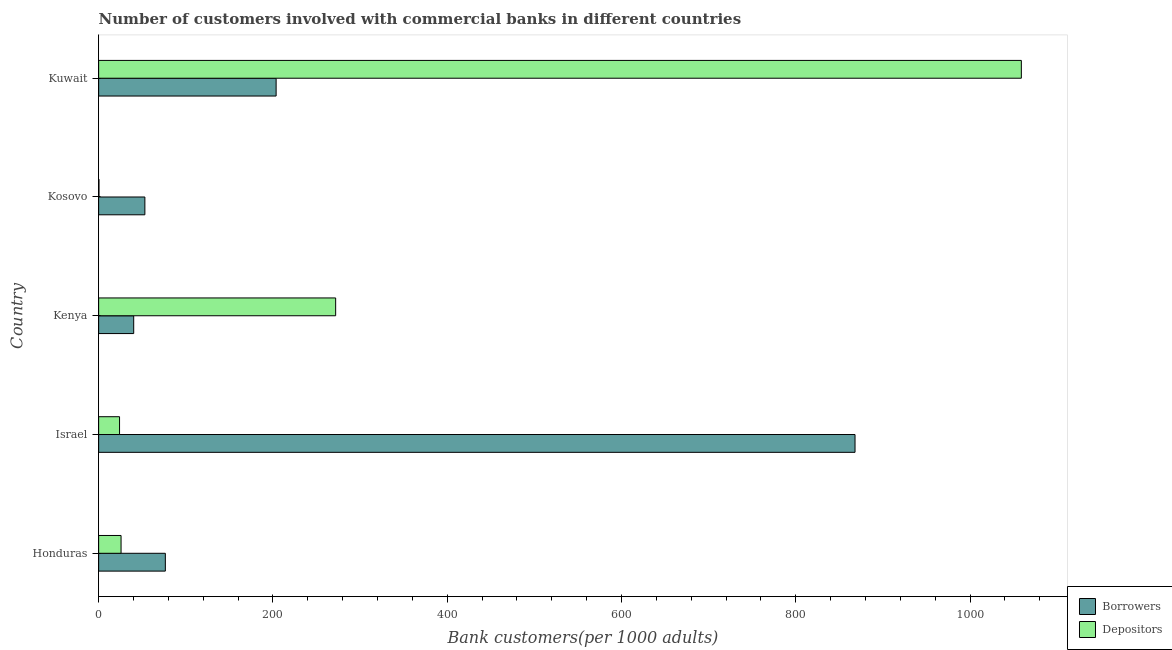How many different coloured bars are there?
Your answer should be very brief. 2. Are the number of bars per tick equal to the number of legend labels?
Ensure brevity in your answer.  Yes. How many bars are there on the 4th tick from the top?
Offer a very short reply. 2. What is the label of the 3rd group of bars from the top?
Ensure brevity in your answer.  Kenya. In how many cases, is the number of bars for a given country not equal to the number of legend labels?
Provide a short and direct response. 0. What is the number of borrowers in Israel?
Offer a very short reply. 867.97. Across all countries, what is the maximum number of borrowers?
Offer a very short reply. 867.97. Across all countries, what is the minimum number of borrowers?
Offer a very short reply. 40.25. In which country was the number of borrowers maximum?
Provide a short and direct response. Israel. In which country was the number of depositors minimum?
Your response must be concise. Kosovo. What is the total number of borrowers in the graph?
Keep it short and to the point. 1241.51. What is the difference between the number of depositors in Kosovo and that in Kuwait?
Your response must be concise. -1058.41. What is the difference between the number of borrowers in Kenya and the number of depositors in Israel?
Offer a terse response. 16.26. What is the average number of depositors per country?
Your response must be concise. 276.19. What is the difference between the number of depositors and number of borrowers in Kosovo?
Make the answer very short. -52.67. What is the ratio of the number of borrowers in Kenya to that in Kuwait?
Provide a short and direct response. 0.2. What is the difference between the highest and the second highest number of borrowers?
Your response must be concise. 664.29. What is the difference between the highest and the lowest number of borrowers?
Your answer should be compact. 827.71. In how many countries, is the number of borrowers greater than the average number of borrowers taken over all countries?
Make the answer very short. 1. What does the 1st bar from the top in Honduras represents?
Provide a short and direct response. Depositors. What does the 1st bar from the bottom in Honduras represents?
Make the answer very short. Borrowers. How many bars are there?
Give a very brief answer. 10. Are all the bars in the graph horizontal?
Provide a short and direct response. Yes. How many countries are there in the graph?
Ensure brevity in your answer.  5. Does the graph contain any zero values?
Keep it short and to the point. No. Does the graph contain grids?
Provide a short and direct response. No. How many legend labels are there?
Offer a terse response. 2. How are the legend labels stacked?
Provide a short and direct response. Vertical. What is the title of the graph?
Keep it short and to the point. Number of customers involved with commercial banks in different countries. Does "current US$" appear as one of the legend labels in the graph?
Provide a short and direct response. No. What is the label or title of the X-axis?
Make the answer very short. Bank customers(per 1000 adults). What is the Bank customers(per 1000 adults) of Borrowers in Honduras?
Your response must be concise. 76.56. What is the Bank customers(per 1000 adults) of Depositors in Honduras?
Offer a terse response. 25.74. What is the Bank customers(per 1000 adults) in Borrowers in Israel?
Ensure brevity in your answer.  867.97. What is the Bank customers(per 1000 adults) in Depositors in Israel?
Provide a succinct answer. 24. What is the Bank customers(per 1000 adults) of Borrowers in Kenya?
Give a very brief answer. 40.25. What is the Bank customers(per 1000 adults) of Depositors in Kenya?
Offer a terse response. 271.98. What is the Bank customers(per 1000 adults) in Borrowers in Kosovo?
Offer a terse response. 53.07. What is the Bank customers(per 1000 adults) in Depositors in Kosovo?
Provide a short and direct response. 0.4. What is the Bank customers(per 1000 adults) of Borrowers in Kuwait?
Make the answer very short. 203.67. What is the Bank customers(per 1000 adults) of Depositors in Kuwait?
Offer a very short reply. 1058.81. Across all countries, what is the maximum Bank customers(per 1000 adults) in Borrowers?
Your answer should be compact. 867.97. Across all countries, what is the maximum Bank customers(per 1000 adults) in Depositors?
Your response must be concise. 1058.81. Across all countries, what is the minimum Bank customers(per 1000 adults) in Borrowers?
Your answer should be compact. 40.25. Across all countries, what is the minimum Bank customers(per 1000 adults) in Depositors?
Give a very brief answer. 0.4. What is the total Bank customers(per 1000 adults) of Borrowers in the graph?
Offer a terse response. 1241.51. What is the total Bank customers(per 1000 adults) of Depositors in the graph?
Provide a short and direct response. 1380.93. What is the difference between the Bank customers(per 1000 adults) in Borrowers in Honduras and that in Israel?
Make the answer very short. -791.41. What is the difference between the Bank customers(per 1000 adults) of Depositors in Honduras and that in Israel?
Make the answer very short. 1.75. What is the difference between the Bank customers(per 1000 adults) of Borrowers in Honduras and that in Kenya?
Keep it short and to the point. 36.3. What is the difference between the Bank customers(per 1000 adults) of Depositors in Honduras and that in Kenya?
Provide a short and direct response. -246.24. What is the difference between the Bank customers(per 1000 adults) in Borrowers in Honduras and that in Kosovo?
Keep it short and to the point. 23.49. What is the difference between the Bank customers(per 1000 adults) in Depositors in Honduras and that in Kosovo?
Your answer should be very brief. 25.35. What is the difference between the Bank customers(per 1000 adults) in Borrowers in Honduras and that in Kuwait?
Ensure brevity in your answer.  -127.12. What is the difference between the Bank customers(per 1000 adults) in Depositors in Honduras and that in Kuwait?
Offer a very short reply. -1033.07. What is the difference between the Bank customers(per 1000 adults) of Borrowers in Israel and that in Kenya?
Your answer should be very brief. 827.71. What is the difference between the Bank customers(per 1000 adults) of Depositors in Israel and that in Kenya?
Ensure brevity in your answer.  -247.99. What is the difference between the Bank customers(per 1000 adults) of Borrowers in Israel and that in Kosovo?
Give a very brief answer. 814.9. What is the difference between the Bank customers(per 1000 adults) of Depositors in Israel and that in Kosovo?
Ensure brevity in your answer.  23.6. What is the difference between the Bank customers(per 1000 adults) of Borrowers in Israel and that in Kuwait?
Make the answer very short. 664.29. What is the difference between the Bank customers(per 1000 adults) of Depositors in Israel and that in Kuwait?
Give a very brief answer. -1034.81. What is the difference between the Bank customers(per 1000 adults) of Borrowers in Kenya and that in Kosovo?
Provide a short and direct response. -12.82. What is the difference between the Bank customers(per 1000 adults) of Depositors in Kenya and that in Kosovo?
Provide a succinct answer. 271.59. What is the difference between the Bank customers(per 1000 adults) in Borrowers in Kenya and that in Kuwait?
Ensure brevity in your answer.  -163.42. What is the difference between the Bank customers(per 1000 adults) in Depositors in Kenya and that in Kuwait?
Provide a succinct answer. -786.83. What is the difference between the Bank customers(per 1000 adults) of Borrowers in Kosovo and that in Kuwait?
Keep it short and to the point. -150.6. What is the difference between the Bank customers(per 1000 adults) in Depositors in Kosovo and that in Kuwait?
Offer a terse response. -1058.41. What is the difference between the Bank customers(per 1000 adults) in Borrowers in Honduras and the Bank customers(per 1000 adults) in Depositors in Israel?
Give a very brief answer. 52.56. What is the difference between the Bank customers(per 1000 adults) of Borrowers in Honduras and the Bank customers(per 1000 adults) of Depositors in Kenya?
Make the answer very short. -195.43. What is the difference between the Bank customers(per 1000 adults) in Borrowers in Honduras and the Bank customers(per 1000 adults) in Depositors in Kosovo?
Offer a very short reply. 76.16. What is the difference between the Bank customers(per 1000 adults) in Borrowers in Honduras and the Bank customers(per 1000 adults) in Depositors in Kuwait?
Make the answer very short. -982.25. What is the difference between the Bank customers(per 1000 adults) in Borrowers in Israel and the Bank customers(per 1000 adults) in Depositors in Kenya?
Your response must be concise. 595.98. What is the difference between the Bank customers(per 1000 adults) of Borrowers in Israel and the Bank customers(per 1000 adults) of Depositors in Kosovo?
Provide a short and direct response. 867.57. What is the difference between the Bank customers(per 1000 adults) of Borrowers in Israel and the Bank customers(per 1000 adults) of Depositors in Kuwait?
Your answer should be compact. -190.84. What is the difference between the Bank customers(per 1000 adults) of Borrowers in Kenya and the Bank customers(per 1000 adults) of Depositors in Kosovo?
Give a very brief answer. 39.85. What is the difference between the Bank customers(per 1000 adults) of Borrowers in Kenya and the Bank customers(per 1000 adults) of Depositors in Kuwait?
Make the answer very short. -1018.56. What is the difference between the Bank customers(per 1000 adults) in Borrowers in Kosovo and the Bank customers(per 1000 adults) in Depositors in Kuwait?
Make the answer very short. -1005.74. What is the average Bank customers(per 1000 adults) in Borrowers per country?
Keep it short and to the point. 248.3. What is the average Bank customers(per 1000 adults) of Depositors per country?
Make the answer very short. 276.19. What is the difference between the Bank customers(per 1000 adults) in Borrowers and Bank customers(per 1000 adults) in Depositors in Honduras?
Offer a very short reply. 50.81. What is the difference between the Bank customers(per 1000 adults) in Borrowers and Bank customers(per 1000 adults) in Depositors in Israel?
Give a very brief answer. 843.97. What is the difference between the Bank customers(per 1000 adults) in Borrowers and Bank customers(per 1000 adults) in Depositors in Kenya?
Your response must be concise. -231.73. What is the difference between the Bank customers(per 1000 adults) of Borrowers and Bank customers(per 1000 adults) of Depositors in Kosovo?
Provide a short and direct response. 52.67. What is the difference between the Bank customers(per 1000 adults) in Borrowers and Bank customers(per 1000 adults) in Depositors in Kuwait?
Provide a short and direct response. -855.14. What is the ratio of the Bank customers(per 1000 adults) in Borrowers in Honduras to that in Israel?
Offer a very short reply. 0.09. What is the ratio of the Bank customers(per 1000 adults) in Depositors in Honduras to that in Israel?
Your answer should be compact. 1.07. What is the ratio of the Bank customers(per 1000 adults) in Borrowers in Honduras to that in Kenya?
Provide a succinct answer. 1.9. What is the ratio of the Bank customers(per 1000 adults) in Depositors in Honduras to that in Kenya?
Give a very brief answer. 0.09. What is the ratio of the Bank customers(per 1000 adults) in Borrowers in Honduras to that in Kosovo?
Offer a very short reply. 1.44. What is the ratio of the Bank customers(per 1000 adults) of Depositors in Honduras to that in Kosovo?
Make the answer very short. 64.86. What is the ratio of the Bank customers(per 1000 adults) of Borrowers in Honduras to that in Kuwait?
Give a very brief answer. 0.38. What is the ratio of the Bank customers(per 1000 adults) of Depositors in Honduras to that in Kuwait?
Offer a very short reply. 0.02. What is the ratio of the Bank customers(per 1000 adults) of Borrowers in Israel to that in Kenya?
Offer a very short reply. 21.56. What is the ratio of the Bank customers(per 1000 adults) in Depositors in Israel to that in Kenya?
Provide a short and direct response. 0.09. What is the ratio of the Bank customers(per 1000 adults) of Borrowers in Israel to that in Kosovo?
Give a very brief answer. 16.36. What is the ratio of the Bank customers(per 1000 adults) of Depositors in Israel to that in Kosovo?
Provide a short and direct response. 60.46. What is the ratio of the Bank customers(per 1000 adults) in Borrowers in Israel to that in Kuwait?
Provide a succinct answer. 4.26. What is the ratio of the Bank customers(per 1000 adults) of Depositors in Israel to that in Kuwait?
Ensure brevity in your answer.  0.02. What is the ratio of the Bank customers(per 1000 adults) of Borrowers in Kenya to that in Kosovo?
Your answer should be compact. 0.76. What is the ratio of the Bank customers(per 1000 adults) in Depositors in Kenya to that in Kosovo?
Provide a short and direct response. 685.33. What is the ratio of the Bank customers(per 1000 adults) of Borrowers in Kenya to that in Kuwait?
Provide a succinct answer. 0.2. What is the ratio of the Bank customers(per 1000 adults) in Depositors in Kenya to that in Kuwait?
Offer a very short reply. 0.26. What is the ratio of the Bank customers(per 1000 adults) of Borrowers in Kosovo to that in Kuwait?
Offer a very short reply. 0.26. What is the difference between the highest and the second highest Bank customers(per 1000 adults) in Borrowers?
Your answer should be very brief. 664.29. What is the difference between the highest and the second highest Bank customers(per 1000 adults) of Depositors?
Give a very brief answer. 786.83. What is the difference between the highest and the lowest Bank customers(per 1000 adults) of Borrowers?
Offer a terse response. 827.71. What is the difference between the highest and the lowest Bank customers(per 1000 adults) of Depositors?
Your answer should be very brief. 1058.41. 